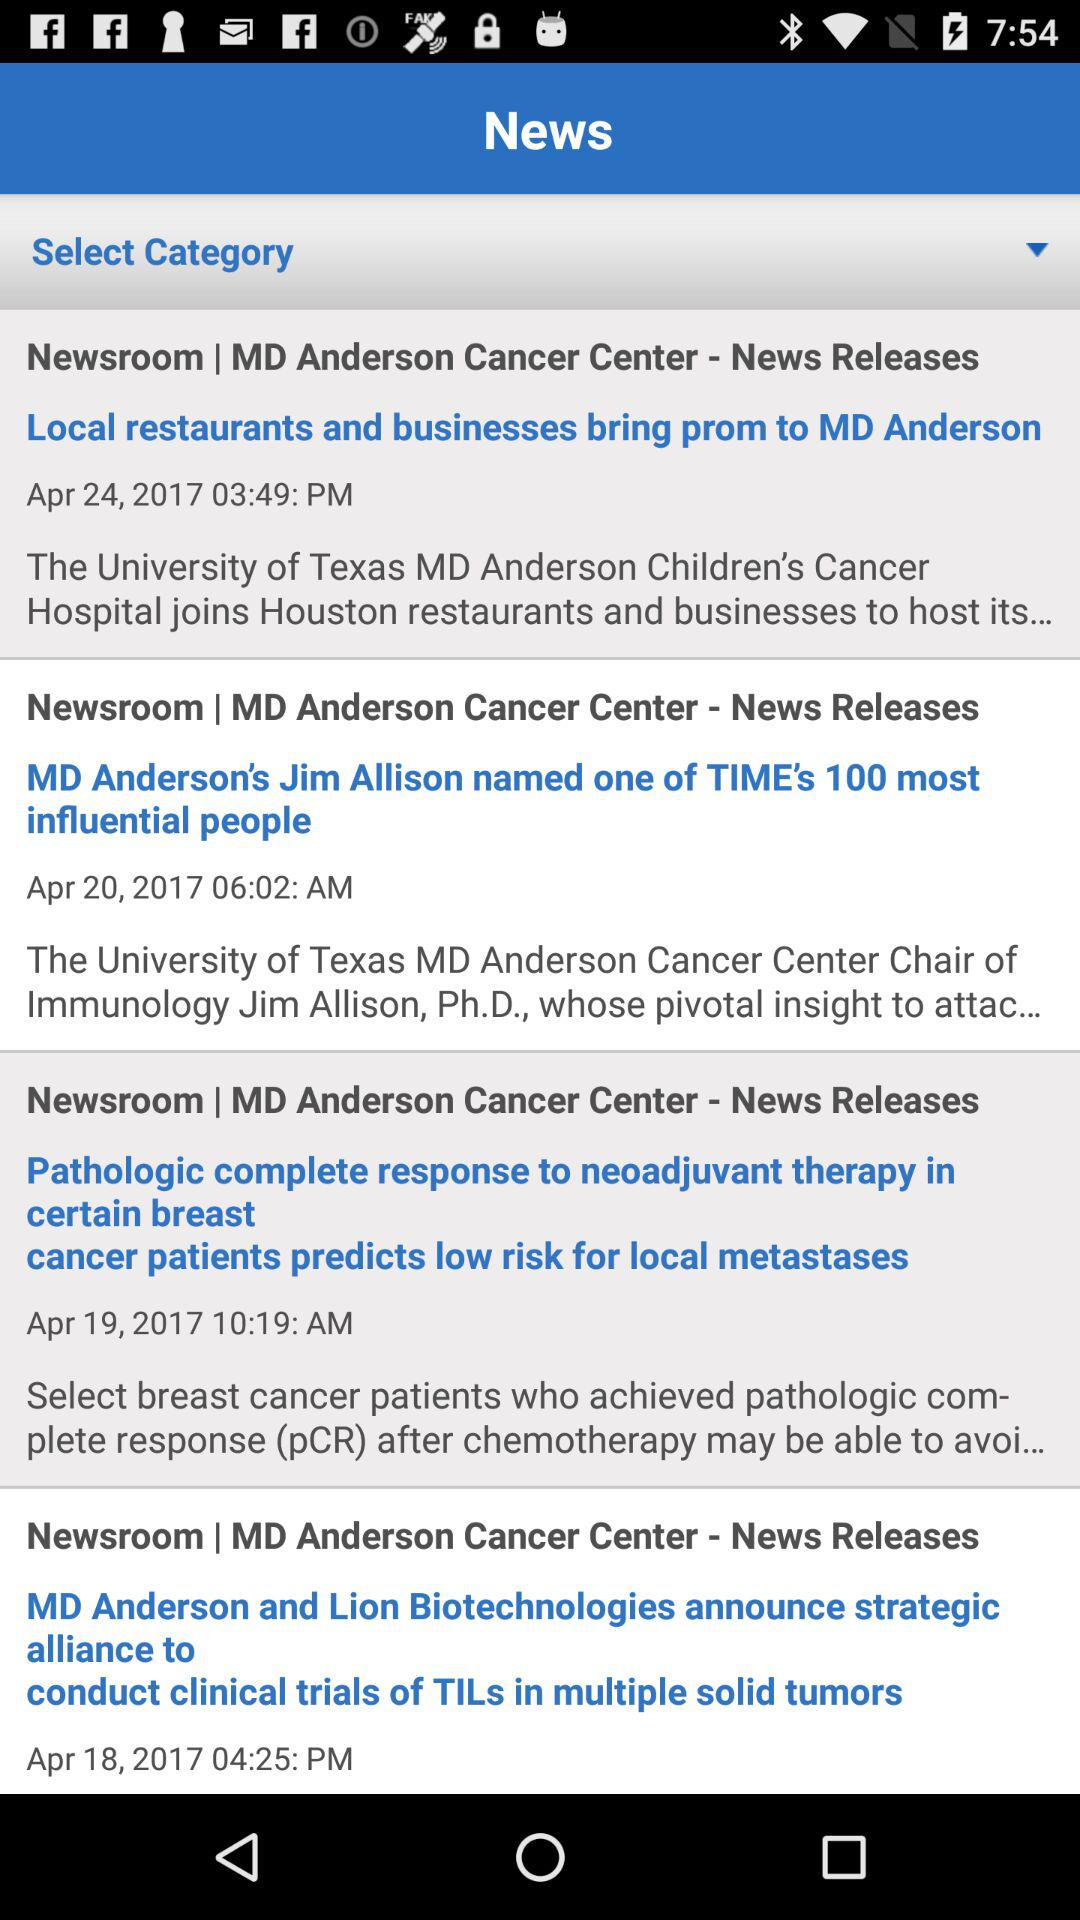What is the time of the news "MD Anderson's Jim Allison named one of TIME's 100 most influential people"? The time is 06:02 AM. 